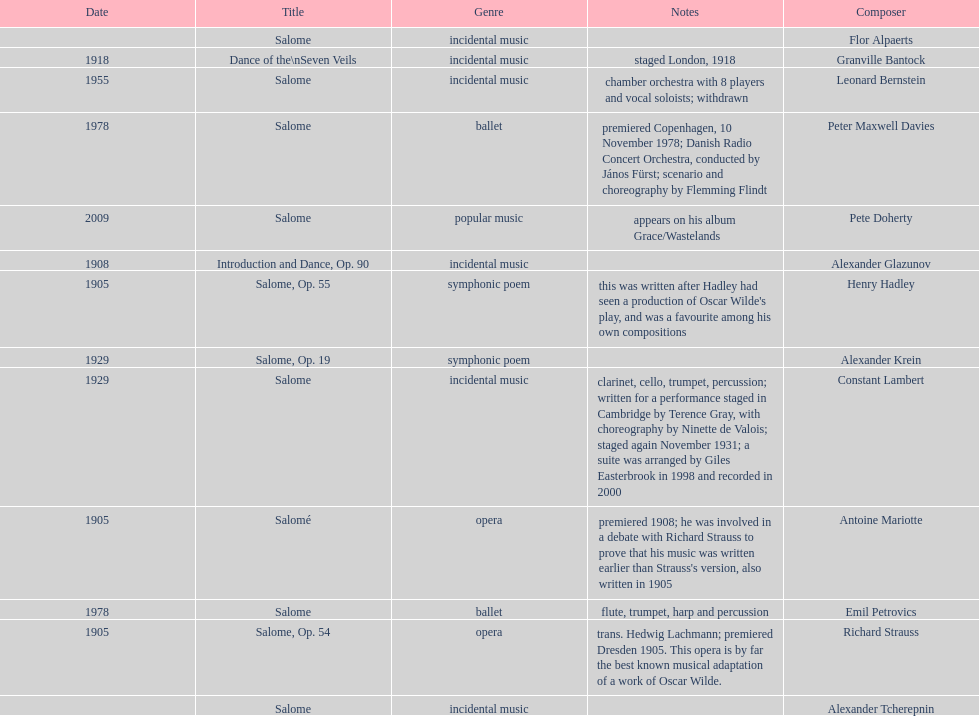Who is on top of the list? Flor Alpaerts. 